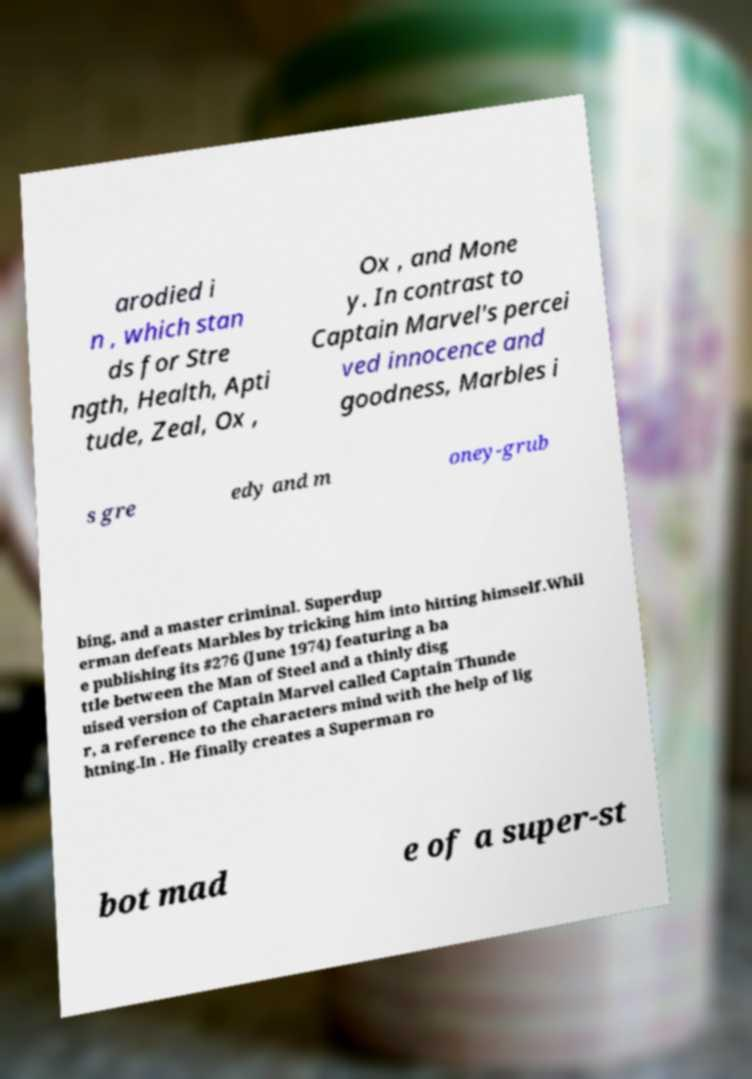There's text embedded in this image that I need extracted. Can you transcribe it verbatim? arodied i n , which stan ds for Stre ngth, Health, Apti tude, Zeal, Ox , Ox , and Mone y. In contrast to Captain Marvel's percei ved innocence and goodness, Marbles i s gre edy and m oney-grub bing, and a master criminal. Superdup erman defeats Marbles by tricking him into hitting himself.Whil e publishing its #276 (June 1974) featuring a ba ttle between the Man of Steel and a thinly disg uised version of Captain Marvel called Captain Thunde r, a reference to the characters mind with the help of lig htning.In . He finally creates a Superman ro bot mad e of a super-st 